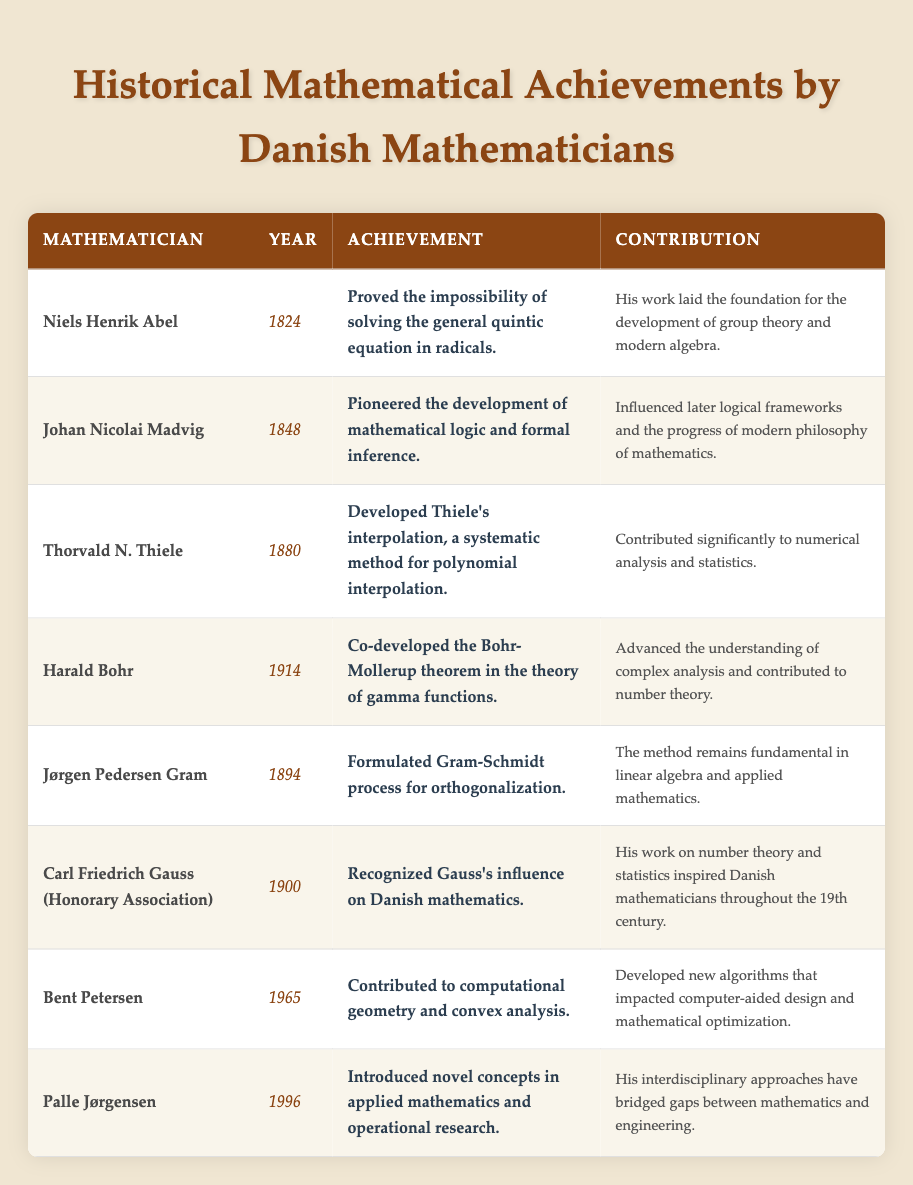What was the achievement of Niels Henrik Abel? According to the table, Niels Henrik Abel's achievement in 1824 was proving the impossibility of solving the general quintic equation in radicals.
Answer: Proved the impossibility of solving the general quintic equation in radicals Who contributed to the Gram-Schmidt process? The table indicates that Jørgen Pedersen Gram formulated the Gram-Schmidt process for orthogonalization in 1894.
Answer: Jørgen Pedersen Gram Which mathematician's work influenced the development of mathematical logic? The table shows that Johan Nicolai Madvig, in 1848, pioneered the development of mathematical logic and formal inference.
Answer: Johan Nicolai Madvig What year did Bent Petersen make his contributions? Looking at the table, Bent Petersen contributed to computational geometry and convex analysis in 1965.
Answer: 1965 Which mathematician's work laid the foundation for group theory? Niels Henrik Abel's work, as noted in the table, laid the foundation for the development of group theory and modern algebra.
Answer: Niels Henrik Abel Did any mathematicians work in the 20th century? Yes, the table lists contributions from Harald Bohr in 1914, Bent Petersen in 1965, and Palle Jørgensen in 1996.
Answer: Yes What is the earliest achievement recorded in the table? The table shows Niels Henrik Abel's achievement in 1824 as the earliest listed achievement.
Answer: 1824 Count the number of achievements related to mathematical logic from the table. The table lists one achievement related to mathematical logic, attributed to Johan Nicolai Madvig in 1848.
Answer: 1 Which mathematician made significant contributions to numerical analysis? The table lists Thorvald N. Thiele, who developed Thiele's interpolation, as the mathematician who contributed significantly to numerical analysis in 1880.
Answer: Thorvald N. Thiele What is the latest achievement year in the table? Upon examining the table, Palle Jørgensen’s achievement in 1996 is the latest year mentioned.
Answer: 1996 Identify the contributions related to number theory in the table. The table indicates Harald Bohr's co-development of the Bohr-Mollerup theorem and Carl Friedrich Gauss's influence in number theory.
Answer: Harald Bohr and Carl Friedrich Gauss How many contributions were made in the 19th century, specifically? The table shows five contributions made in the 19th century (1824, 1848, 1880, 1894, and 1900).
Answer: 5 Was there a recognized influence from Gauss on Danish mathematics, according to the table? Yes, the table clearly states that Carl Friedrich Gauss's work on number theory and statistics inspired Danish mathematicians throughout the 19th century.
Answer: Yes Which mathematician's work bridged gaps between mathematics and engineering? Palle Jørgensen is mentioned in the table for introducing novel concepts in applied mathematics and operational research, bridging gaps between mathematics and engineering in 1996.
Answer: Palle Jørgensen What is the significance of the Gram-Schmidt process? According to the table, the Gram-Schmidt process remains fundamental in linear algebra and applied mathematics, contributing to orthogonalization.
Answer: Fundamental in linear algebra and applied mathematics How many mathematicians contributed to the field of applied mathematics, according to the table? The table notes that both Palle Jørgensen and Johan Nicolai Madvig contributed to the field of applied mathematics, indicating two contributions.
Answer: 2 